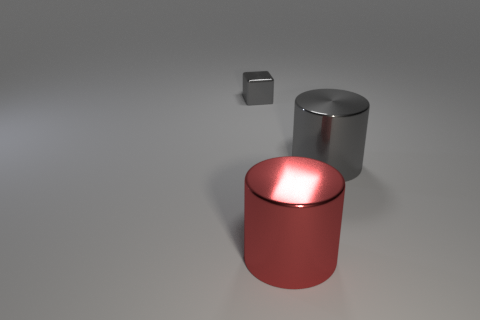Add 1 red metal things. How many objects exist? 4 Subtract all blocks. How many objects are left? 2 Add 3 red shiny cylinders. How many red shiny cylinders exist? 4 Subtract 0 brown cubes. How many objects are left? 3 Subtract all gray cubes. Subtract all big gray cylinders. How many objects are left? 1 Add 2 big gray metal cylinders. How many big gray metal cylinders are left? 3 